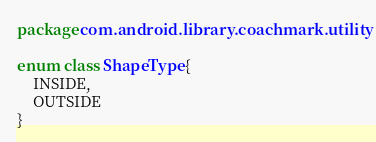<code> <loc_0><loc_0><loc_500><loc_500><_Kotlin_>package com.android.library.coachmark.utility

enum class ShapeType {
    INSIDE,
    OUTSIDE
}</code> 